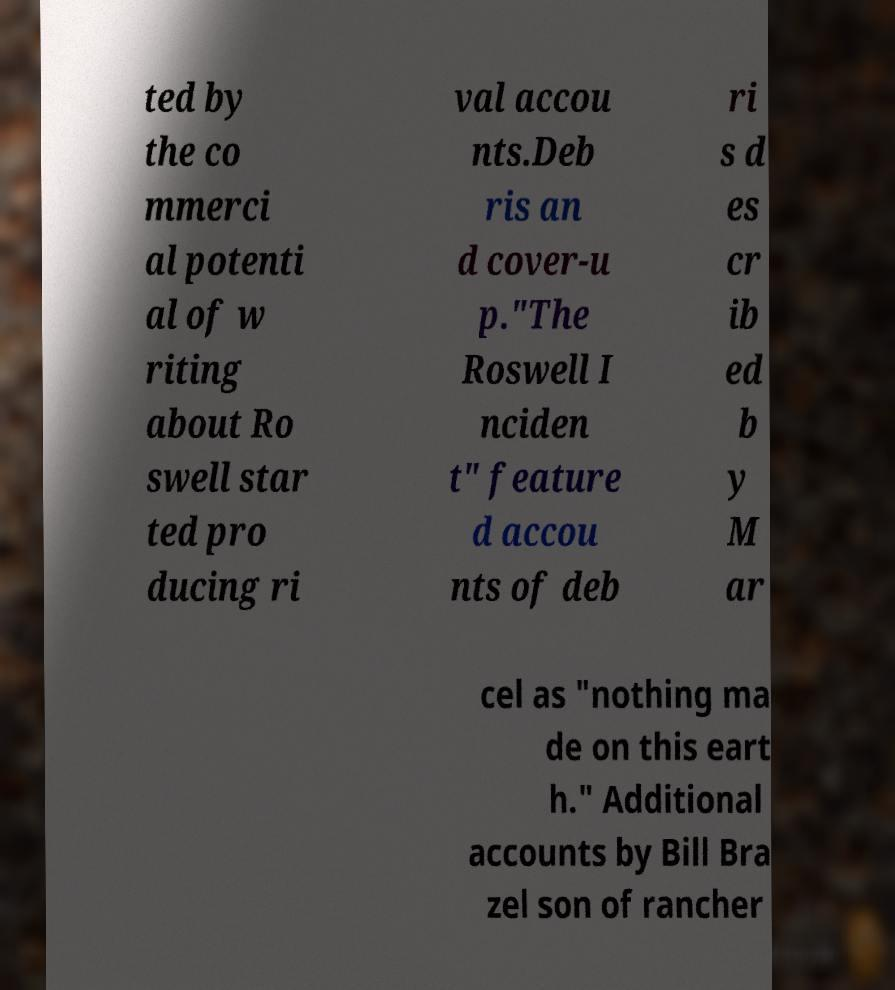Could you extract and type out the text from this image? ted by the co mmerci al potenti al of w riting about Ro swell star ted pro ducing ri val accou nts.Deb ris an d cover-u p."The Roswell I nciden t" feature d accou nts of deb ri s d es cr ib ed b y M ar cel as "nothing ma de on this eart h." Additional accounts by Bill Bra zel son of rancher 